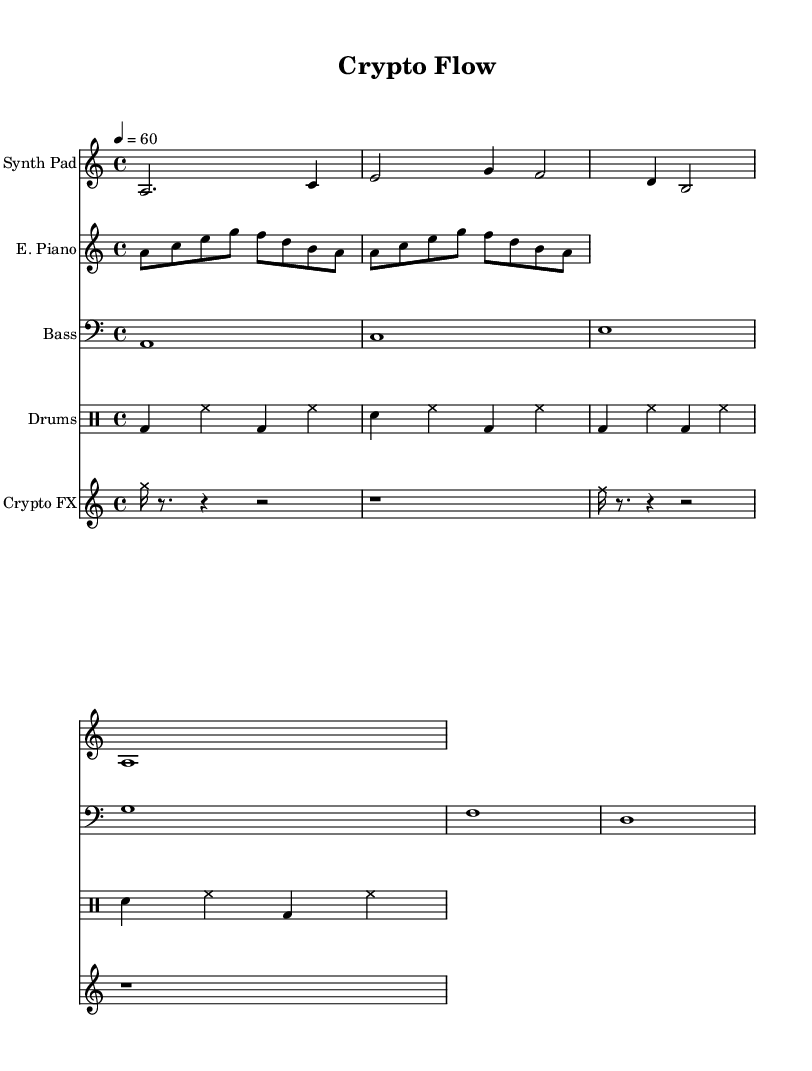What is the key signature of this music? The key signature is A minor, which has no sharps or flats, indicated by the 'a' written in lowercase at the beginning of the piece.
Answer: A minor What is the time signature of this music? The time signature is 4/4, which is indicated by the '4' above '4' at the beginning of the score, meaning there are four beats in a measure.
Answer: 4/4 What is the tempo marking for this piece? The tempo marking is 60 beats per minute, indicated by the '4 = 60' under the tempo line, which tells the speed of the music.
Answer: 60 How many measures does the Synth Pad section contain? The Synth Pad section contains 2 measures, as indicated by the two distinct groups of notes separated by bar lines.
Answer: 2 What type of notes are used in the Crypto FX staff at the beginning? The Crypto FX staff uses cross note heads for sound effects, indicated by the override note head style set to 'cross' at the beginning of the section, which distinguishes them from standard notes.
Answer: Cross How many different instruments are featured in the score? There are 5 different instruments featured in the score, as indicated by the five separate staffs labeled as Synth Pad, E. Piano, Bass, Drums, and Crypto FX.
Answer: 5 What rhythmic pattern is primarily used in the Drum Machine section? The rhythmic pattern in the Drum Machine section consists of alternating bass drums and snare hits, with the beats structured in a consistent repeating pattern, indicated by the drum notation.
Answer: Alternating bass and snare 